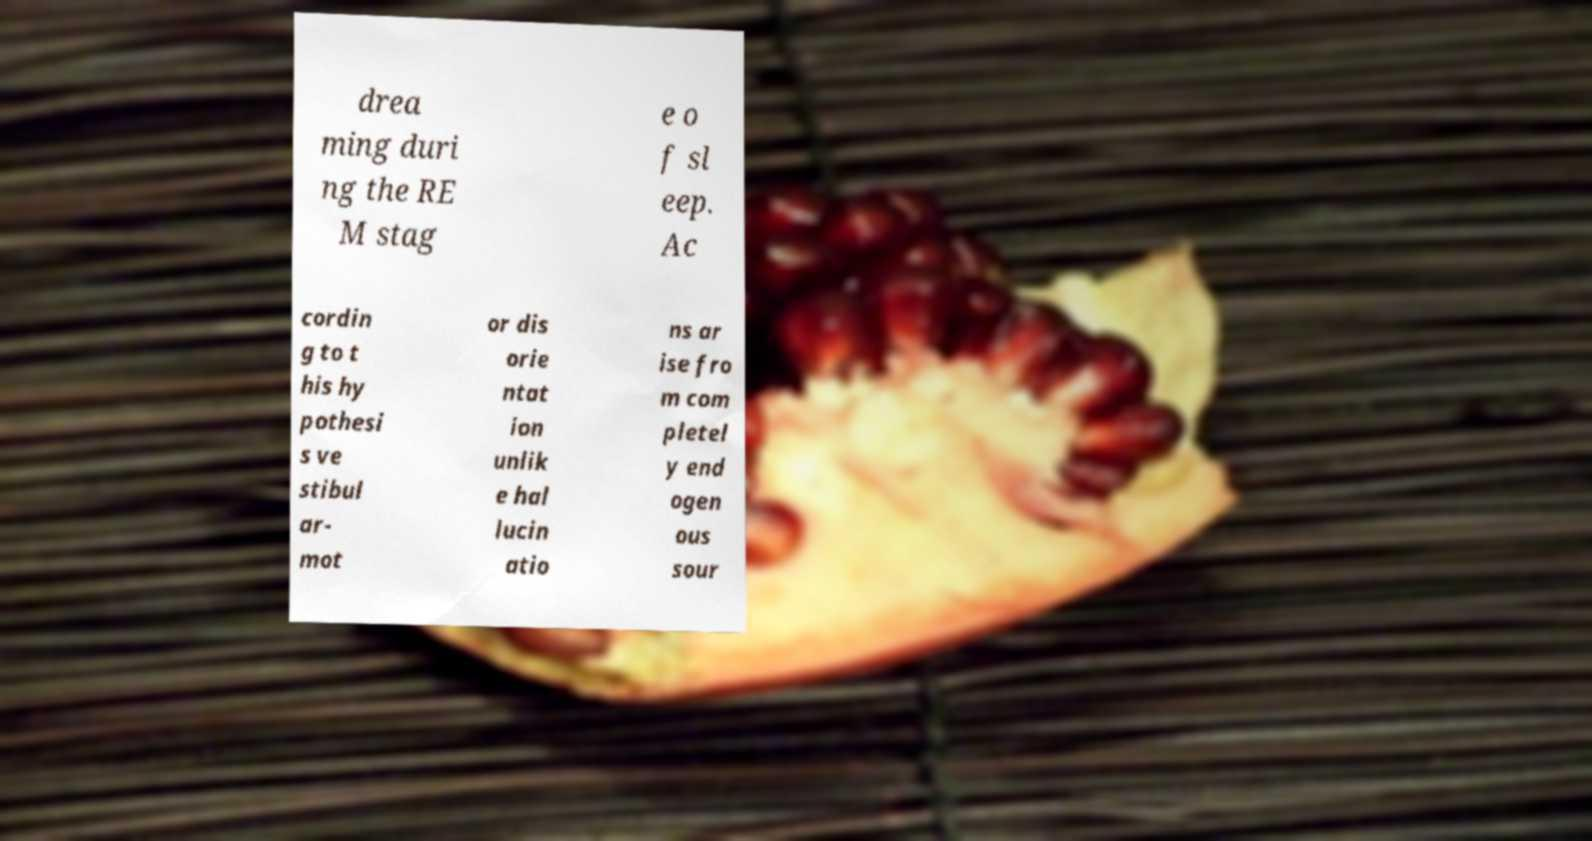There's text embedded in this image that I need extracted. Can you transcribe it verbatim? drea ming duri ng the RE M stag e o f sl eep. Ac cordin g to t his hy pothesi s ve stibul ar- mot or dis orie ntat ion unlik e hal lucin atio ns ar ise fro m com pletel y end ogen ous sour 